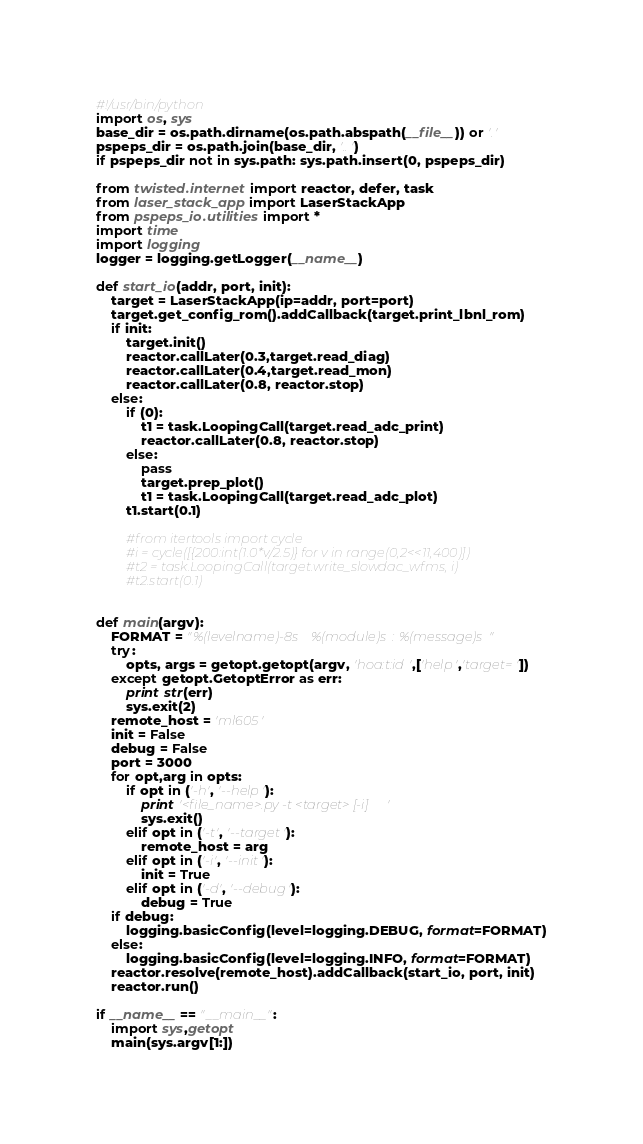Convert code to text. <code><loc_0><loc_0><loc_500><loc_500><_Python_>#!/usr/bin/python
import os, sys
base_dir = os.path.dirname(os.path.abspath(__file__)) or '.'
pspeps_dir = os.path.join(base_dir, '..')
if pspeps_dir not in sys.path: sys.path.insert(0, pspeps_dir)

from twisted.internet import reactor, defer, task
from laser_stack_app import LaserStackApp
from pspeps_io.utilities import *
import time
import logging
logger = logging.getLogger(__name__)

def start_io(addr, port, init):
    target = LaserStackApp(ip=addr, port=port)
    target.get_config_rom().addCallback(target.print_lbnl_rom)
    if init:
        target.init()
        reactor.callLater(0.3,target.read_diag)
        reactor.callLater(0.4,target.read_mon)
        reactor.callLater(0.8, reactor.stop)
    else:
        if (0):
            t1 = task.LoopingCall(target.read_adc_print)
            reactor.callLater(0.8, reactor.stop)
        else:
            pass
            target.prep_plot()
            t1 = task.LoopingCall(target.read_adc_plot)
        t1.start(0.1)

        #from itertools import cycle
        #i = cycle([{200:int(1.0*v/2.5)} for v in range(0,2<<11,400)])
        #t2 = task.LoopingCall(target.write_slowdac_wfms, i)
        #t2.start(0.1)


def main(argv):
    FORMAT = "%(levelname)-8s %(module)s: %(message)s"
    try:
        opts, args = getopt.getopt(argv, 'hoa:t:id',['help','target='])
    except getopt.GetoptError as err:
        print str(err)
        sys.exit(2)
    remote_host = 'ml605'
    init = False
    debug = False
    port = 3000
    for opt,arg in opts:
        if opt in ('-h', '--help'):
            print '<file_name>.py -t <target> [-i]'
            sys.exit()
        elif opt in ('-t', '--target'):
            remote_host = arg
        elif opt in ('-i', '--init'):
            init = True
        elif opt in ('-d', '--debug'):
            debug = True
    if debug:
        logging.basicConfig(level=logging.DEBUG, format=FORMAT)
    else:
        logging.basicConfig(level=logging.INFO, format=FORMAT)
    reactor.resolve(remote_host).addCallback(start_io, port, init)
    reactor.run()

if __name__ == "__main__":
    import sys,getopt
    main(sys.argv[1:])
</code> 